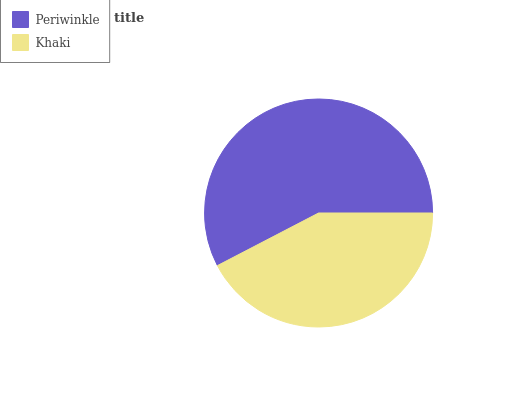Is Khaki the minimum?
Answer yes or no. Yes. Is Periwinkle the maximum?
Answer yes or no. Yes. Is Khaki the maximum?
Answer yes or no. No. Is Periwinkle greater than Khaki?
Answer yes or no. Yes. Is Khaki less than Periwinkle?
Answer yes or no. Yes. Is Khaki greater than Periwinkle?
Answer yes or no. No. Is Periwinkle less than Khaki?
Answer yes or no. No. Is Periwinkle the high median?
Answer yes or no. Yes. Is Khaki the low median?
Answer yes or no. Yes. Is Khaki the high median?
Answer yes or no. No. Is Periwinkle the low median?
Answer yes or no. No. 